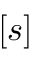<formula> <loc_0><loc_0><loc_500><loc_500>[ s ]</formula> 